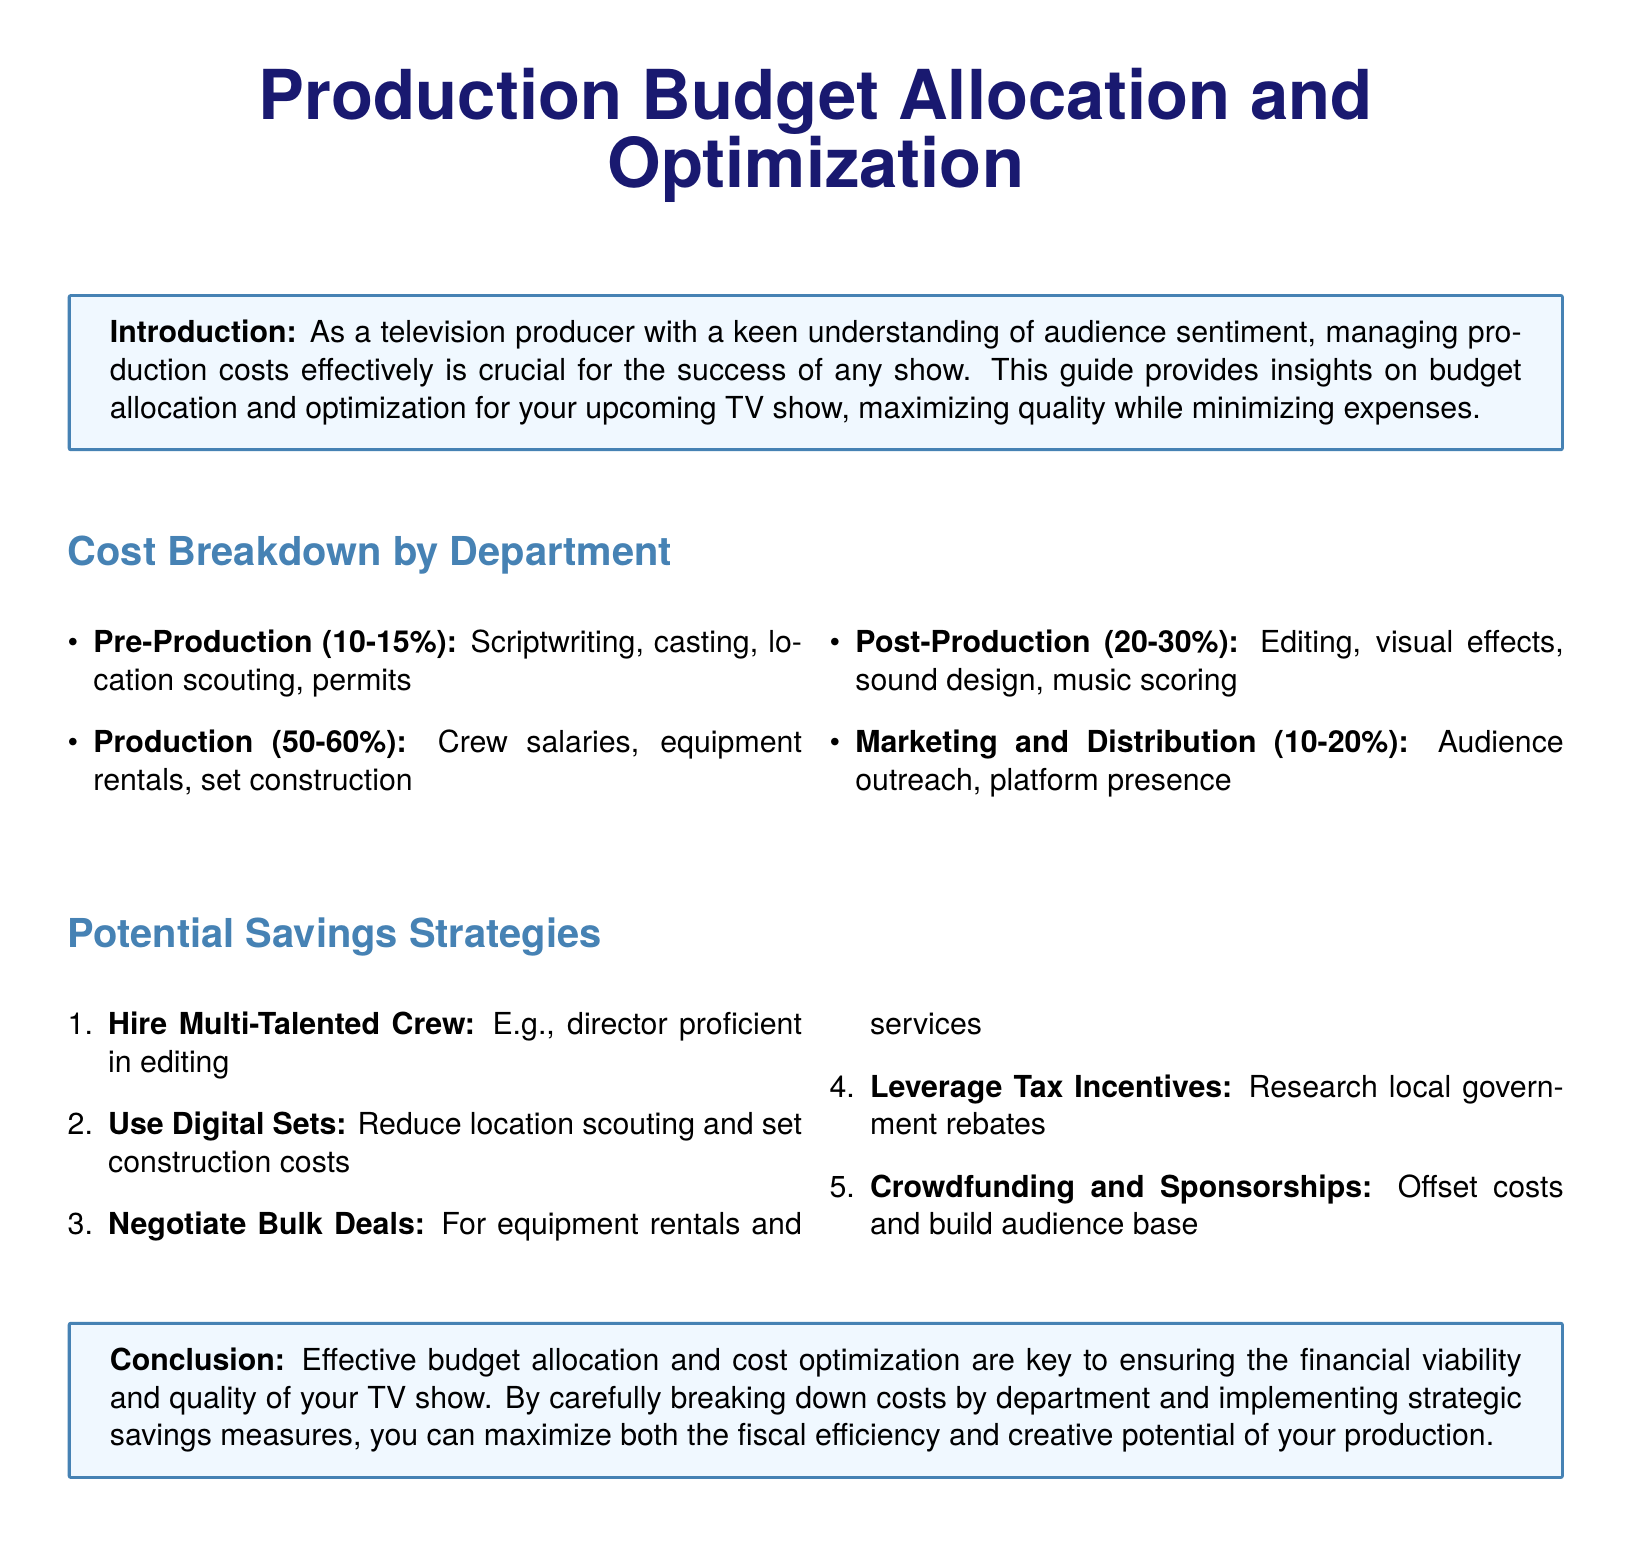what percentage of the budget is allocated to Pre-Production? The document states that Pre-Production constitutes 10-15% of the budget.
Answer: 10-15% what is the largest percentage range for the Production budget? The document mentions that Production takes 50-60% of the overall budget.
Answer: 50-60% what is one potential savings strategy mentioned in the document? The document lists several strategies, including hiring a multi-talented crew.
Answer: hire multi-talented crew how much of the budget is earmarked for Post-Production? The budget allocation for Post-Production is 20-30% according to the document.
Answer: 20-30% what is the total percentage range for Marketing and Distribution costs? The document indicates that Marketing and Distribution comprise 10-20% of the budget.
Answer: 10-20% what key benefit is highlighted for leveraging tax incentives? The document suggests that researching local government rebates can lead to cost offsets.
Answer: cost offsets what is the primary focus of the Production budget allocation guide? The document emphasizes effective management of production costs for TV shows.
Answer: effective management of production costs what strategic advantage does using digital sets provide? The document notes that digital sets can help reduce location scouting and set construction costs.
Answer: reduce costs what does the document classify as the main focus of the Introduction? The document's Introduction outlines the importance of managing production costs effectively.
Answer: managing production costs effectively 